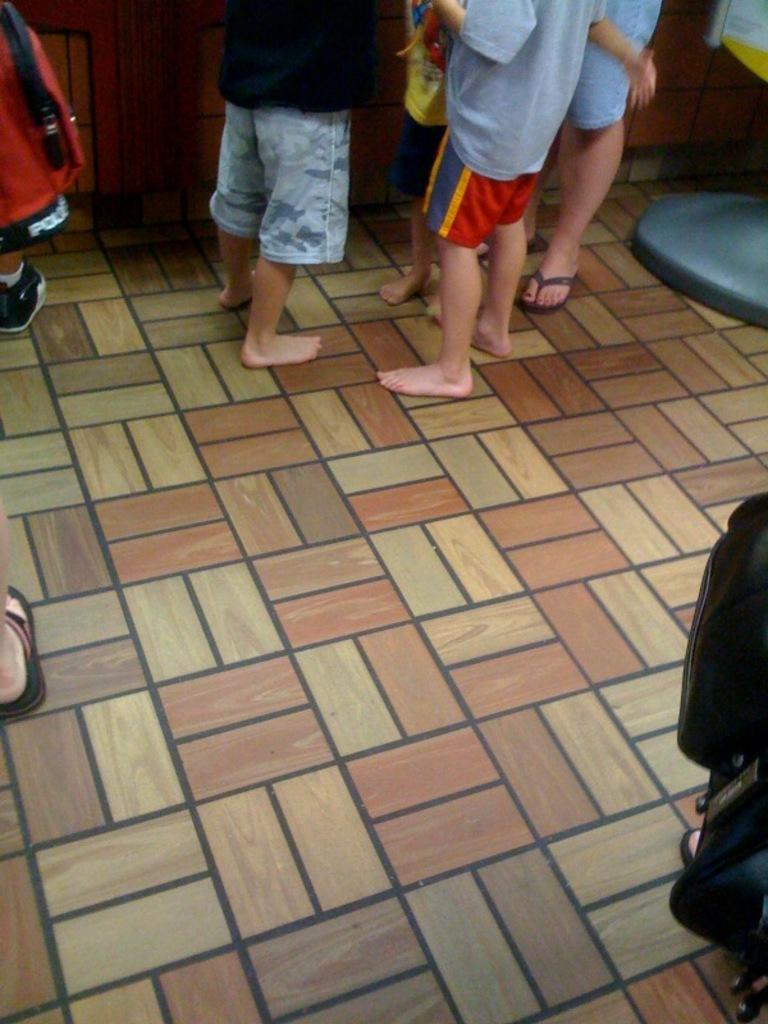How many individuals are present in the image? There is a group of people in the image. What is the position of the people in the image? The people are standing on the floor. What type of test is being conducted in the image? There is no test being conducted in the image; it simply shows a group of people standing on the floor. 